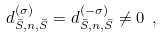Convert formula to latex. <formula><loc_0><loc_0><loc_500><loc_500>d ^ { ( \sigma ) } _ { \bar { S } , n , \bar { S } } = d ^ { ( - \sigma ) } _ { \bar { S } , n , \bar { S } } \neq 0 \ ,</formula> 